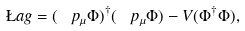Convert formula to latex. <formula><loc_0><loc_0><loc_500><loc_500>\L a g = ( \ p _ { \mu } { \Phi } ) ^ { \dagger } ( \ p _ { \mu } \Phi ) - V ( { \Phi } ^ { \dagger } \Phi ) ,</formula> 